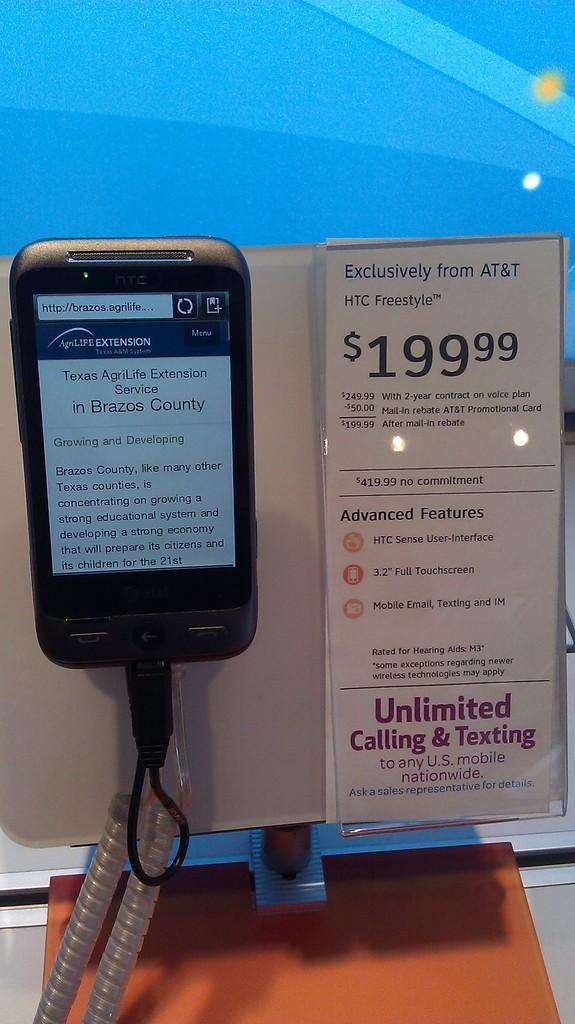<image>
Present a compact description of the photo's key features. the AT&T phone is for sale for $199.99 